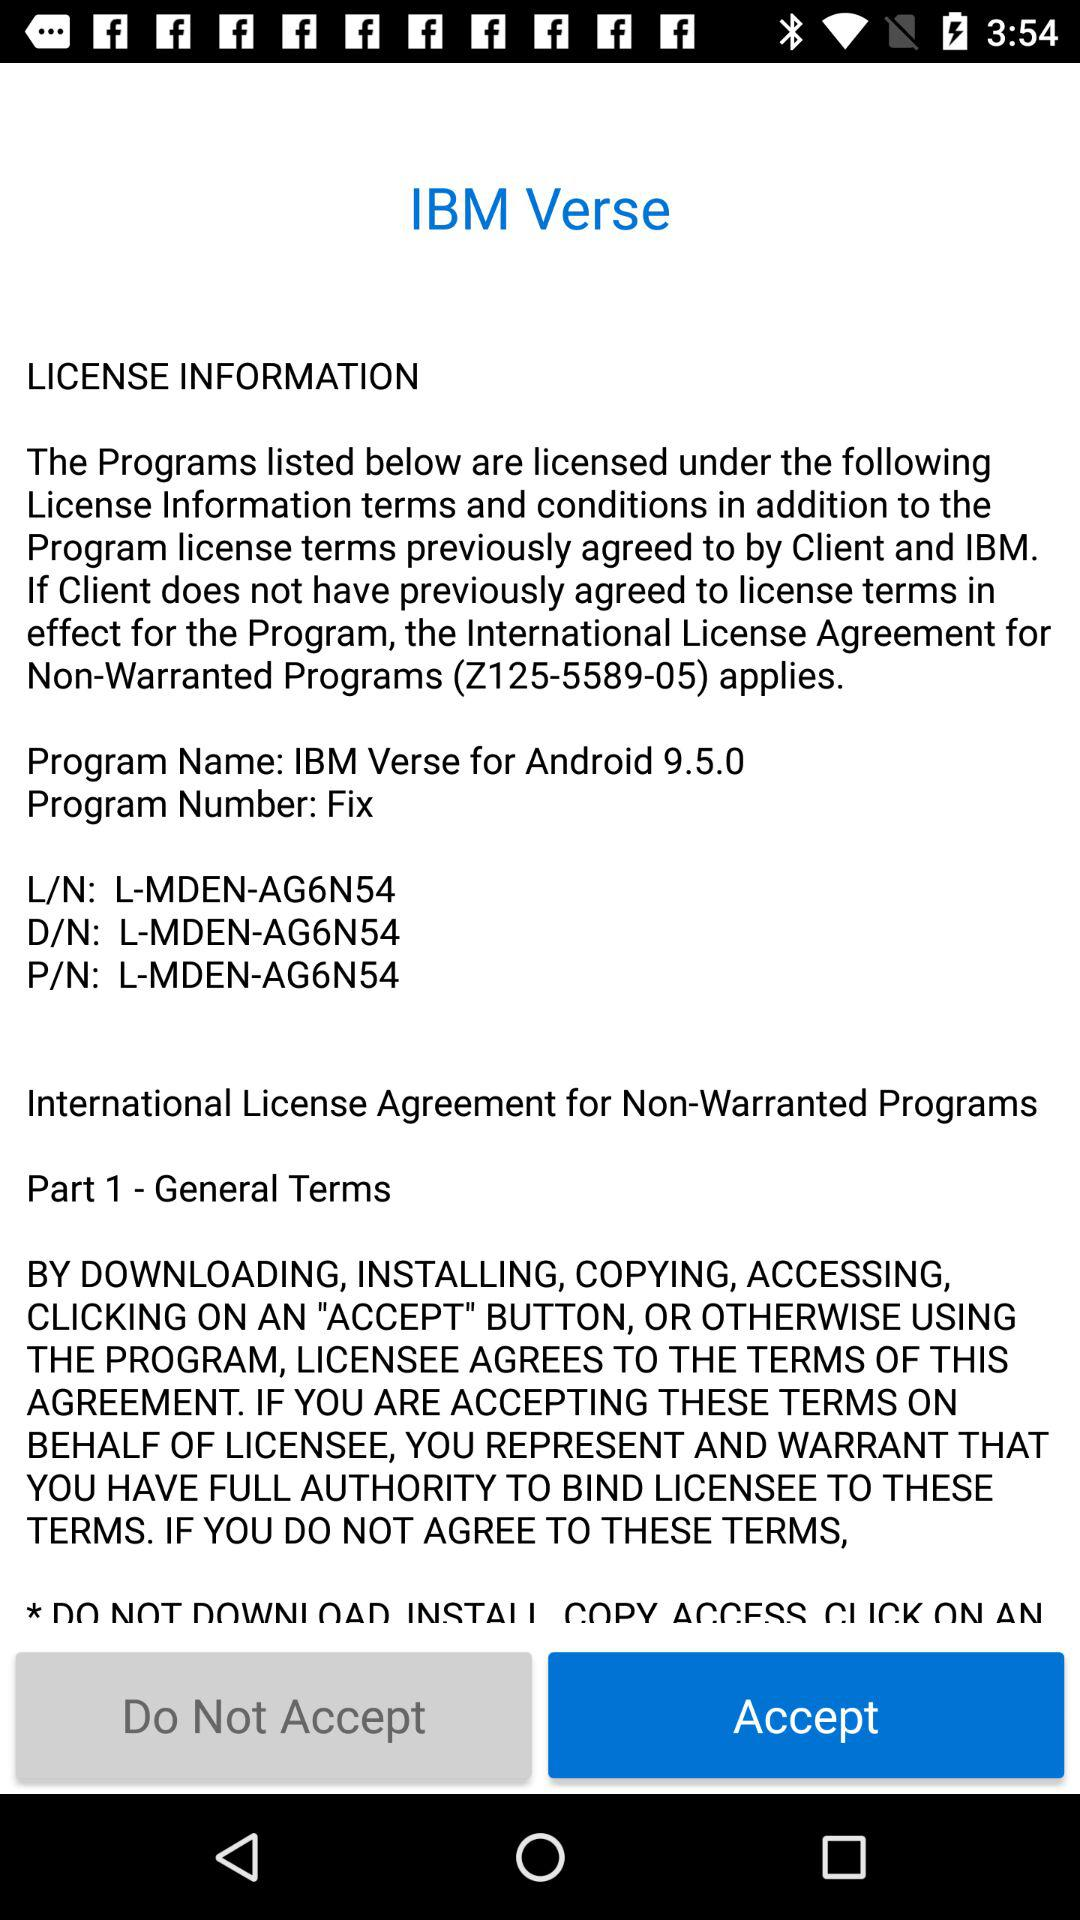What is the program name for the verse? The program name for the verse is IBM Verse for Android 9.5.0. 